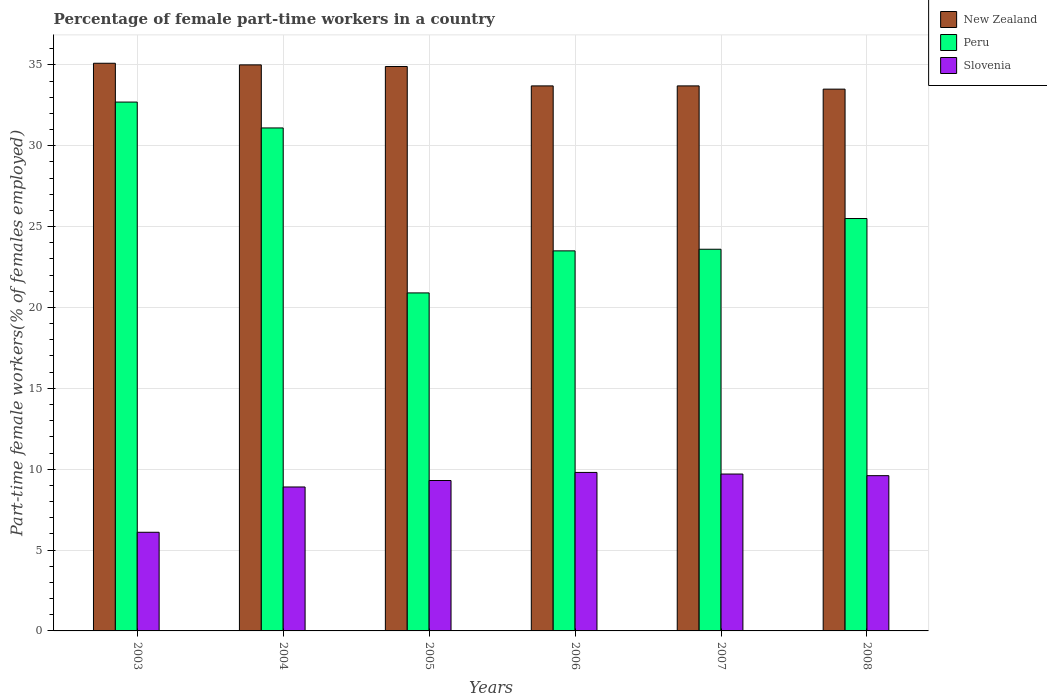Are the number of bars on each tick of the X-axis equal?
Keep it short and to the point. Yes. How many bars are there on the 2nd tick from the left?
Provide a succinct answer. 3. How many bars are there on the 3rd tick from the right?
Make the answer very short. 3. What is the label of the 2nd group of bars from the left?
Your response must be concise. 2004. In how many cases, is the number of bars for a given year not equal to the number of legend labels?
Offer a terse response. 0. What is the percentage of female part-time workers in Slovenia in 2004?
Give a very brief answer. 8.9. Across all years, what is the maximum percentage of female part-time workers in Slovenia?
Your response must be concise. 9.8. Across all years, what is the minimum percentage of female part-time workers in Peru?
Offer a very short reply. 20.9. In which year was the percentage of female part-time workers in Slovenia maximum?
Provide a short and direct response. 2006. What is the total percentage of female part-time workers in New Zealand in the graph?
Provide a short and direct response. 205.9. What is the difference between the percentage of female part-time workers in Slovenia in 2003 and that in 2007?
Provide a short and direct response. -3.6. What is the difference between the percentage of female part-time workers in New Zealand in 2007 and the percentage of female part-time workers in Peru in 2004?
Offer a terse response. 2.6. What is the average percentage of female part-time workers in Peru per year?
Offer a terse response. 26.22. In the year 2005, what is the difference between the percentage of female part-time workers in Slovenia and percentage of female part-time workers in New Zealand?
Provide a short and direct response. -25.6. What is the ratio of the percentage of female part-time workers in Slovenia in 2007 to that in 2008?
Provide a succinct answer. 1.01. What is the difference between the highest and the second highest percentage of female part-time workers in Slovenia?
Make the answer very short. 0.1. What is the difference between the highest and the lowest percentage of female part-time workers in Peru?
Make the answer very short. 11.8. In how many years, is the percentage of female part-time workers in Peru greater than the average percentage of female part-time workers in Peru taken over all years?
Your answer should be very brief. 2. Is the sum of the percentage of female part-time workers in Slovenia in 2005 and 2008 greater than the maximum percentage of female part-time workers in Peru across all years?
Make the answer very short. No. What does the 2nd bar from the left in 2007 represents?
Make the answer very short. Peru. What does the 1st bar from the right in 2008 represents?
Provide a short and direct response. Slovenia. Is it the case that in every year, the sum of the percentage of female part-time workers in Peru and percentage of female part-time workers in New Zealand is greater than the percentage of female part-time workers in Slovenia?
Make the answer very short. Yes. How many bars are there?
Provide a succinct answer. 18. Are the values on the major ticks of Y-axis written in scientific E-notation?
Your answer should be compact. No. Does the graph contain any zero values?
Ensure brevity in your answer.  No. Where does the legend appear in the graph?
Your answer should be very brief. Top right. How many legend labels are there?
Provide a succinct answer. 3. What is the title of the graph?
Give a very brief answer. Percentage of female part-time workers in a country. What is the label or title of the Y-axis?
Your answer should be very brief. Part-time female workers(% of females employed). What is the Part-time female workers(% of females employed) in New Zealand in 2003?
Give a very brief answer. 35.1. What is the Part-time female workers(% of females employed) of Peru in 2003?
Provide a succinct answer. 32.7. What is the Part-time female workers(% of females employed) of Slovenia in 2003?
Keep it short and to the point. 6.1. What is the Part-time female workers(% of females employed) in New Zealand in 2004?
Your answer should be very brief. 35. What is the Part-time female workers(% of females employed) in Peru in 2004?
Offer a terse response. 31.1. What is the Part-time female workers(% of females employed) in Slovenia in 2004?
Offer a terse response. 8.9. What is the Part-time female workers(% of females employed) of New Zealand in 2005?
Your answer should be compact. 34.9. What is the Part-time female workers(% of females employed) of Peru in 2005?
Offer a terse response. 20.9. What is the Part-time female workers(% of females employed) of Slovenia in 2005?
Offer a very short reply. 9.3. What is the Part-time female workers(% of females employed) in New Zealand in 2006?
Your answer should be very brief. 33.7. What is the Part-time female workers(% of females employed) in Slovenia in 2006?
Provide a succinct answer. 9.8. What is the Part-time female workers(% of females employed) of New Zealand in 2007?
Keep it short and to the point. 33.7. What is the Part-time female workers(% of females employed) of Peru in 2007?
Provide a short and direct response. 23.6. What is the Part-time female workers(% of females employed) in Slovenia in 2007?
Your answer should be compact. 9.7. What is the Part-time female workers(% of females employed) of New Zealand in 2008?
Keep it short and to the point. 33.5. What is the Part-time female workers(% of females employed) in Peru in 2008?
Your answer should be very brief. 25.5. What is the Part-time female workers(% of females employed) in Slovenia in 2008?
Provide a succinct answer. 9.6. Across all years, what is the maximum Part-time female workers(% of females employed) in New Zealand?
Ensure brevity in your answer.  35.1. Across all years, what is the maximum Part-time female workers(% of females employed) in Peru?
Ensure brevity in your answer.  32.7. Across all years, what is the maximum Part-time female workers(% of females employed) in Slovenia?
Keep it short and to the point. 9.8. Across all years, what is the minimum Part-time female workers(% of females employed) in New Zealand?
Provide a succinct answer. 33.5. Across all years, what is the minimum Part-time female workers(% of females employed) of Peru?
Give a very brief answer. 20.9. Across all years, what is the minimum Part-time female workers(% of females employed) in Slovenia?
Provide a short and direct response. 6.1. What is the total Part-time female workers(% of females employed) of New Zealand in the graph?
Offer a very short reply. 205.9. What is the total Part-time female workers(% of females employed) of Peru in the graph?
Offer a terse response. 157.3. What is the total Part-time female workers(% of females employed) in Slovenia in the graph?
Offer a terse response. 53.4. What is the difference between the Part-time female workers(% of females employed) of New Zealand in 2003 and that in 2004?
Ensure brevity in your answer.  0.1. What is the difference between the Part-time female workers(% of females employed) of Peru in 2003 and that in 2004?
Offer a terse response. 1.6. What is the difference between the Part-time female workers(% of females employed) of Slovenia in 2003 and that in 2005?
Provide a short and direct response. -3.2. What is the difference between the Part-time female workers(% of females employed) of Peru in 2003 and that in 2006?
Your answer should be very brief. 9.2. What is the difference between the Part-time female workers(% of females employed) of Slovenia in 2003 and that in 2006?
Make the answer very short. -3.7. What is the difference between the Part-time female workers(% of females employed) in Peru in 2003 and that in 2008?
Offer a terse response. 7.2. What is the difference between the Part-time female workers(% of females employed) in Slovenia in 2003 and that in 2008?
Provide a succinct answer. -3.5. What is the difference between the Part-time female workers(% of females employed) of New Zealand in 2004 and that in 2006?
Provide a short and direct response. 1.3. What is the difference between the Part-time female workers(% of females employed) in Peru in 2004 and that in 2006?
Keep it short and to the point. 7.6. What is the difference between the Part-time female workers(% of females employed) in Slovenia in 2004 and that in 2006?
Provide a short and direct response. -0.9. What is the difference between the Part-time female workers(% of females employed) of Slovenia in 2004 and that in 2007?
Provide a succinct answer. -0.8. What is the difference between the Part-time female workers(% of females employed) in New Zealand in 2004 and that in 2008?
Give a very brief answer. 1.5. What is the difference between the Part-time female workers(% of females employed) in Slovenia in 2004 and that in 2008?
Your answer should be compact. -0.7. What is the difference between the Part-time female workers(% of females employed) of Slovenia in 2005 and that in 2006?
Your answer should be very brief. -0.5. What is the difference between the Part-time female workers(% of females employed) in Peru in 2005 and that in 2008?
Ensure brevity in your answer.  -4.6. What is the difference between the Part-time female workers(% of females employed) of Slovenia in 2005 and that in 2008?
Your response must be concise. -0.3. What is the difference between the Part-time female workers(% of females employed) of New Zealand in 2006 and that in 2007?
Offer a very short reply. 0. What is the difference between the Part-time female workers(% of females employed) in Peru in 2006 and that in 2007?
Give a very brief answer. -0.1. What is the difference between the Part-time female workers(% of females employed) in Slovenia in 2006 and that in 2007?
Offer a terse response. 0.1. What is the difference between the Part-time female workers(% of females employed) of Peru in 2006 and that in 2008?
Offer a very short reply. -2. What is the difference between the Part-time female workers(% of females employed) of Slovenia in 2006 and that in 2008?
Provide a succinct answer. 0.2. What is the difference between the Part-time female workers(% of females employed) of New Zealand in 2007 and that in 2008?
Give a very brief answer. 0.2. What is the difference between the Part-time female workers(% of females employed) in Peru in 2007 and that in 2008?
Your answer should be compact. -1.9. What is the difference between the Part-time female workers(% of females employed) of Slovenia in 2007 and that in 2008?
Your answer should be compact. 0.1. What is the difference between the Part-time female workers(% of females employed) of New Zealand in 2003 and the Part-time female workers(% of females employed) of Peru in 2004?
Your response must be concise. 4. What is the difference between the Part-time female workers(% of females employed) of New Zealand in 2003 and the Part-time female workers(% of females employed) of Slovenia in 2004?
Your answer should be very brief. 26.2. What is the difference between the Part-time female workers(% of females employed) in Peru in 2003 and the Part-time female workers(% of females employed) in Slovenia in 2004?
Your answer should be very brief. 23.8. What is the difference between the Part-time female workers(% of females employed) in New Zealand in 2003 and the Part-time female workers(% of females employed) in Slovenia in 2005?
Keep it short and to the point. 25.8. What is the difference between the Part-time female workers(% of females employed) in Peru in 2003 and the Part-time female workers(% of females employed) in Slovenia in 2005?
Provide a succinct answer. 23.4. What is the difference between the Part-time female workers(% of females employed) in New Zealand in 2003 and the Part-time female workers(% of females employed) in Slovenia in 2006?
Offer a terse response. 25.3. What is the difference between the Part-time female workers(% of females employed) of Peru in 2003 and the Part-time female workers(% of females employed) of Slovenia in 2006?
Make the answer very short. 22.9. What is the difference between the Part-time female workers(% of females employed) of New Zealand in 2003 and the Part-time female workers(% of females employed) of Peru in 2007?
Give a very brief answer. 11.5. What is the difference between the Part-time female workers(% of females employed) of New Zealand in 2003 and the Part-time female workers(% of females employed) of Slovenia in 2007?
Provide a succinct answer. 25.4. What is the difference between the Part-time female workers(% of females employed) of New Zealand in 2003 and the Part-time female workers(% of females employed) of Slovenia in 2008?
Provide a succinct answer. 25.5. What is the difference between the Part-time female workers(% of females employed) in Peru in 2003 and the Part-time female workers(% of females employed) in Slovenia in 2008?
Provide a short and direct response. 23.1. What is the difference between the Part-time female workers(% of females employed) in New Zealand in 2004 and the Part-time female workers(% of females employed) in Peru in 2005?
Your answer should be very brief. 14.1. What is the difference between the Part-time female workers(% of females employed) of New Zealand in 2004 and the Part-time female workers(% of females employed) of Slovenia in 2005?
Ensure brevity in your answer.  25.7. What is the difference between the Part-time female workers(% of females employed) in Peru in 2004 and the Part-time female workers(% of females employed) in Slovenia in 2005?
Keep it short and to the point. 21.8. What is the difference between the Part-time female workers(% of females employed) of New Zealand in 2004 and the Part-time female workers(% of females employed) of Peru in 2006?
Ensure brevity in your answer.  11.5. What is the difference between the Part-time female workers(% of females employed) in New Zealand in 2004 and the Part-time female workers(% of females employed) in Slovenia in 2006?
Your response must be concise. 25.2. What is the difference between the Part-time female workers(% of females employed) in Peru in 2004 and the Part-time female workers(% of females employed) in Slovenia in 2006?
Give a very brief answer. 21.3. What is the difference between the Part-time female workers(% of females employed) of New Zealand in 2004 and the Part-time female workers(% of females employed) of Peru in 2007?
Provide a succinct answer. 11.4. What is the difference between the Part-time female workers(% of females employed) in New Zealand in 2004 and the Part-time female workers(% of females employed) in Slovenia in 2007?
Provide a short and direct response. 25.3. What is the difference between the Part-time female workers(% of females employed) in Peru in 2004 and the Part-time female workers(% of females employed) in Slovenia in 2007?
Provide a succinct answer. 21.4. What is the difference between the Part-time female workers(% of females employed) in New Zealand in 2004 and the Part-time female workers(% of females employed) in Peru in 2008?
Your answer should be compact. 9.5. What is the difference between the Part-time female workers(% of females employed) of New Zealand in 2004 and the Part-time female workers(% of females employed) of Slovenia in 2008?
Keep it short and to the point. 25.4. What is the difference between the Part-time female workers(% of females employed) of New Zealand in 2005 and the Part-time female workers(% of females employed) of Slovenia in 2006?
Offer a terse response. 25.1. What is the difference between the Part-time female workers(% of females employed) in New Zealand in 2005 and the Part-time female workers(% of females employed) in Slovenia in 2007?
Offer a terse response. 25.2. What is the difference between the Part-time female workers(% of females employed) of Peru in 2005 and the Part-time female workers(% of females employed) of Slovenia in 2007?
Offer a terse response. 11.2. What is the difference between the Part-time female workers(% of females employed) of New Zealand in 2005 and the Part-time female workers(% of females employed) of Peru in 2008?
Give a very brief answer. 9.4. What is the difference between the Part-time female workers(% of females employed) in New Zealand in 2005 and the Part-time female workers(% of females employed) in Slovenia in 2008?
Offer a very short reply. 25.3. What is the difference between the Part-time female workers(% of females employed) of Peru in 2005 and the Part-time female workers(% of females employed) of Slovenia in 2008?
Keep it short and to the point. 11.3. What is the difference between the Part-time female workers(% of females employed) of New Zealand in 2006 and the Part-time female workers(% of females employed) of Peru in 2007?
Make the answer very short. 10.1. What is the difference between the Part-time female workers(% of females employed) in New Zealand in 2006 and the Part-time female workers(% of females employed) in Peru in 2008?
Keep it short and to the point. 8.2. What is the difference between the Part-time female workers(% of females employed) in New Zealand in 2006 and the Part-time female workers(% of females employed) in Slovenia in 2008?
Your answer should be very brief. 24.1. What is the difference between the Part-time female workers(% of females employed) in New Zealand in 2007 and the Part-time female workers(% of females employed) in Peru in 2008?
Give a very brief answer. 8.2. What is the difference between the Part-time female workers(% of females employed) of New Zealand in 2007 and the Part-time female workers(% of females employed) of Slovenia in 2008?
Keep it short and to the point. 24.1. What is the difference between the Part-time female workers(% of females employed) in Peru in 2007 and the Part-time female workers(% of females employed) in Slovenia in 2008?
Your answer should be very brief. 14. What is the average Part-time female workers(% of females employed) in New Zealand per year?
Offer a very short reply. 34.32. What is the average Part-time female workers(% of females employed) of Peru per year?
Give a very brief answer. 26.22. What is the average Part-time female workers(% of females employed) of Slovenia per year?
Make the answer very short. 8.9. In the year 2003, what is the difference between the Part-time female workers(% of females employed) in New Zealand and Part-time female workers(% of females employed) in Peru?
Your answer should be compact. 2.4. In the year 2003, what is the difference between the Part-time female workers(% of females employed) in New Zealand and Part-time female workers(% of females employed) in Slovenia?
Offer a terse response. 29. In the year 2003, what is the difference between the Part-time female workers(% of females employed) of Peru and Part-time female workers(% of females employed) of Slovenia?
Ensure brevity in your answer.  26.6. In the year 2004, what is the difference between the Part-time female workers(% of females employed) of New Zealand and Part-time female workers(% of females employed) of Peru?
Offer a terse response. 3.9. In the year 2004, what is the difference between the Part-time female workers(% of females employed) in New Zealand and Part-time female workers(% of females employed) in Slovenia?
Offer a terse response. 26.1. In the year 2005, what is the difference between the Part-time female workers(% of females employed) of New Zealand and Part-time female workers(% of females employed) of Slovenia?
Your answer should be very brief. 25.6. In the year 2005, what is the difference between the Part-time female workers(% of females employed) of Peru and Part-time female workers(% of females employed) of Slovenia?
Keep it short and to the point. 11.6. In the year 2006, what is the difference between the Part-time female workers(% of females employed) in New Zealand and Part-time female workers(% of females employed) in Slovenia?
Your response must be concise. 23.9. In the year 2007, what is the difference between the Part-time female workers(% of females employed) in New Zealand and Part-time female workers(% of females employed) in Peru?
Your response must be concise. 10.1. In the year 2007, what is the difference between the Part-time female workers(% of females employed) of New Zealand and Part-time female workers(% of females employed) of Slovenia?
Your answer should be very brief. 24. In the year 2007, what is the difference between the Part-time female workers(% of females employed) in Peru and Part-time female workers(% of females employed) in Slovenia?
Ensure brevity in your answer.  13.9. In the year 2008, what is the difference between the Part-time female workers(% of females employed) of New Zealand and Part-time female workers(% of females employed) of Slovenia?
Offer a terse response. 23.9. What is the ratio of the Part-time female workers(% of females employed) in New Zealand in 2003 to that in 2004?
Offer a very short reply. 1. What is the ratio of the Part-time female workers(% of females employed) in Peru in 2003 to that in 2004?
Ensure brevity in your answer.  1.05. What is the ratio of the Part-time female workers(% of females employed) of Slovenia in 2003 to that in 2004?
Offer a terse response. 0.69. What is the ratio of the Part-time female workers(% of females employed) in New Zealand in 2003 to that in 2005?
Make the answer very short. 1.01. What is the ratio of the Part-time female workers(% of females employed) in Peru in 2003 to that in 2005?
Keep it short and to the point. 1.56. What is the ratio of the Part-time female workers(% of females employed) in Slovenia in 2003 to that in 2005?
Your answer should be compact. 0.66. What is the ratio of the Part-time female workers(% of females employed) in New Zealand in 2003 to that in 2006?
Offer a terse response. 1.04. What is the ratio of the Part-time female workers(% of females employed) of Peru in 2003 to that in 2006?
Your answer should be compact. 1.39. What is the ratio of the Part-time female workers(% of females employed) of Slovenia in 2003 to that in 2006?
Make the answer very short. 0.62. What is the ratio of the Part-time female workers(% of females employed) of New Zealand in 2003 to that in 2007?
Provide a succinct answer. 1.04. What is the ratio of the Part-time female workers(% of females employed) in Peru in 2003 to that in 2007?
Your answer should be very brief. 1.39. What is the ratio of the Part-time female workers(% of females employed) of Slovenia in 2003 to that in 2007?
Offer a very short reply. 0.63. What is the ratio of the Part-time female workers(% of females employed) of New Zealand in 2003 to that in 2008?
Ensure brevity in your answer.  1.05. What is the ratio of the Part-time female workers(% of females employed) in Peru in 2003 to that in 2008?
Provide a short and direct response. 1.28. What is the ratio of the Part-time female workers(% of females employed) in Slovenia in 2003 to that in 2008?
Keep it short and to the point. 0.64. What is the ratio of the Part-time female workers(% of females employed) of New Zealand in 2004 to that in 2005?
Ensure brevity in your answer.  1. What is the ratio of the Part-time female workers(% of females employed) in Peru in 2004 to that in 2005?
Offer a very short reply. 1.49. What is the ratio of the Part-time female workers(% of females employed) of New Zealand in 2004 to that in 2006?
Ensure brevity in your answer.  1.04. What is the ratio of the Part-time female workers(% of females employed) in Peru in 2004 to that in 2006?
Your answer should be very brief. 1.32. What is the ratio of the Part-time female workers(% of females employed) of Slovenia in 2004 to that in 2006?
Your answer should be very brief. 0.91. What is the ratio of the Part-time female workers(% of females employed) of New Zealand in 2004 to that in 2007?
Offer a very short reply. 1.04. What is the ratio of the Part-time female workers(% of females employed) in Peru in 2004 to that in 2007?
Your answer should be very brief. 1.32. What is the ratio of the Part-time female workers(% of females employed) in Slovenia in 2004 to that in 2007?
Offer a very short reply. 0.92. What is the ratio of the Part-time female workers(% of females employed) of New Zealand in 2004 to that in 2008?
Provide a short and direct response. 1.04. What is the ratio of the Part-time female workers(% of females employed) in Peru in 2004 to that in 2008?
Ensure brevity in your answer.  1.22. What is the ratio of the Part-time female workers(% of females employed) of Slovenia in 2004 to that in 2008?
Offer a very short reply. 0.93. What is the ratio of the Part-time female workers(% of females employed) in New Zealand in 2005 to that in 2006?
Give a very brief answer. 1.04. What is the ratio of the Part-time female workers(% of females employed) in Peru in 2005 to that in 2006?
Provide a succinct answer. 0.89. What is the ratio of the Part-time female workers(% of females employed) in Slovenia in 2005 to that in 2006?
Make the answer very short. 0.95. What is the ratio of the Part-time female workers(% of females employed) of New Zealand in 2005 to that in 2007?
Keep it short and to the point. 1.04. What is the ratio of the Part-time female workers(% of females employed) of Peru in 2005 to that in 2007?
Offer a very short reply. 0.89. What is the ratio of the Part-time female workers(% of females employed) in Slovenia in 2005 to that in 2007?
Your response must be concise. 0.96. What is the ratio of the Part-time female workers(% of females employed) in New Zealand in 2005 to that in 2008?
Give a very brief answer. 1.04. What is the ratio of the Part-time female workers(% of females employed) of Peru in 2005 to that in 2008?
Offer a terse response. 0.82. What is the ratio of the Part-time female workers(% of females employed) in Slovenia in 2005 to that in 2008?
Your answer should be compact. 0.97. What is the ratio of the Part-time female workers(% of females employed) in New Zealand in 2006 to that in 2007?
Keep it short and to the point. 1. What is the ratio of the Part-time female workers(% of females employed) in Slovenia in 2006 to that in 2007?
Offer a very short reply. 1.01. What is the ratio of the Part-time female workers(% of females employed) in New Zealand in 2006 to that in 2008?
Ensure brevity in your answer.  1.01. What is the ratio of the Part-time female workers(% of females employed) of Peru in 2006 to that in 2008?
Make the answer very short. 0.92. What is the ratio of the Part-time female workers(% of females employed) in Slovenia in 2006 to that in 2008?
Ensure brevity in your answer.  1.02. What is the ratio of the Part-time female workers(% of females employed) in Peru in 2007 to that in 2008?
Provide a succinct answer. 0.93. What is the ratio of the Part-time female workers(% of females employed) of Slovenia in 2007 to that in 2008?
Offer a terse response. 1.01. What is the difference between the highest and the second highest Part-time female workers(% of females employed) in New Zealand?
Your response must be concise. 0.1. What is the difference between the highest and the second highest Part-time female workers(% of females employed) of Peru?
Offer a very short reply. 1.6. What is the difference between the highest and the second highest Part-time female workers(% of females employed) of Slovenia?
Ensure brevity in your answer.  0.1. What is the difference between the highest and the lowest Part-time female workers(% of females employed) of New Zealand?
Your answer should be compact. 1.6. What is the difference between the highest and the lowest Part-time female workers(% of females employed) in Slovenia?
Offer a very short reply. 3.7. 